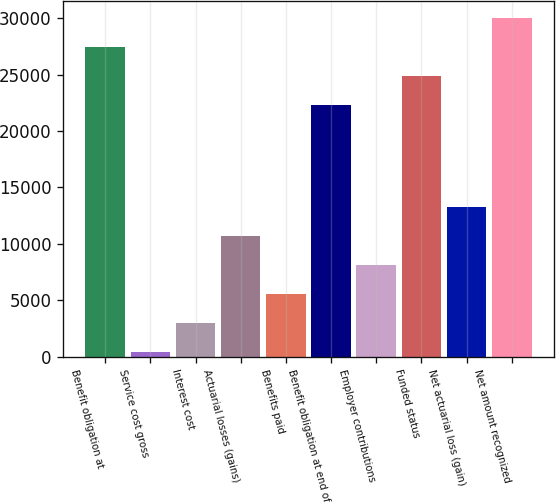Convert chart. <chart><loc_0><loc_0><loc_500><loc_500><bar_chart><fcel>Benefit obligation at<fcel>Service cost gross<fcel>Interest cost<fcel>Actuarial losses (gains)<fcel>Benefits paid<fcel>Benefit obligation at end of<fcel>Employer contributions<fcel>Funded status<fcel>Net actuarial loss (gain)<fcel>Net amount recognized<nl><fcel>27431.4<fcel>405<fcel>2979.7<fcel>10703.8<fcel>5554.4<fcel>22282<fcel>8129.1<fcel>24856.7<fcel>13278.5<fcel>30006.1<nl></chart> 